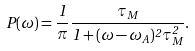<formula> <loc_0><loc_0><loc_500><loc_500>P ( \omega ) = \frac { 1 } { \pi } \frac { \tau _ { M } } { 1 + ( \omega - \omega _ { A } ) ^ { 2 } \tau _ { M } ^ { 2 } } .</formula> 